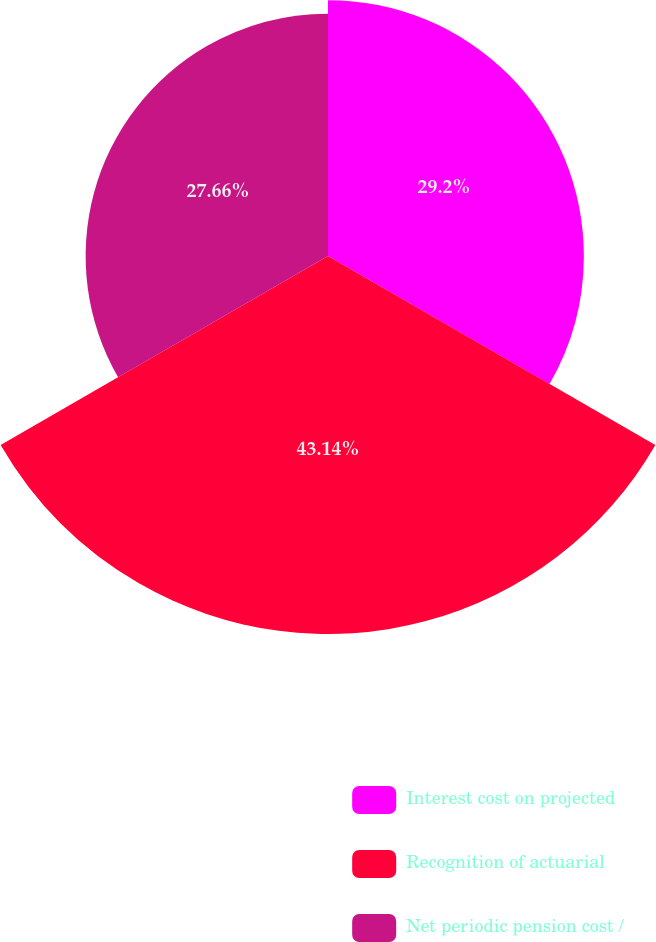<chart> <loc_0><loc_0><loc_500><loc_500><pie_chart><fcel>Interest cost on projected<fcel>Recognition of actuarial<fcel>Net periodic pension cost /<nl><fcel>29.2%<fcel>43.14%<fcel>27.66%<nl></chart> 